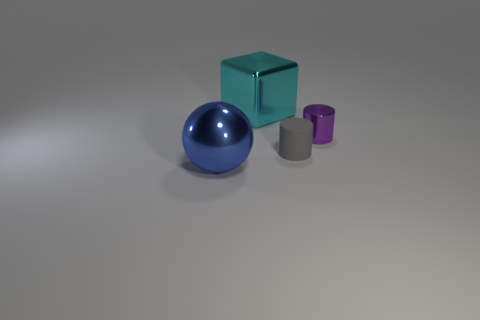Is there anything else that is the same material as the gray thing?
Offer a very short reply. No. What shape is the purple shiny object that is the same size as the gray rubber object?
Ensure brevity in your answer.  Cylinder. Are there any small matte cylinders on the left side of the tiny gray matte cylinder that is in front of the tiny purple metallic cylinder?
Your response must be concise. No. The other tiny rubber thing that is the same shape as the purple thing is what color?
Your answer should be compact. Gray. Does the object that is left of the cyan thing have the same color as the small rubber object?
Ensure brevity in your answer.  No. What number of objects are either metallic objects on the right side of the big shiny block or large purple shiny blocks?
Offer a terse response. 1. What material is the large object behind the big metallic thing that is in front of the large metallic thing that is behind the large blue metal object made of?
Provide a short and direct response. Metal. Are there more gray cylinders that are behind the large metallic block than cubes that are in front of the small rubber cylinder?
Ensure brevity in your answer.  No. How many balls are either tiny metallic things or blue objects?
Give a very brief answer. 1. There is a big thing that is behind the big metal object that is in front of the rubber cylinder; what number of gray rubber cylinders are in front of it?
Ensure brevity in your answer.  1. 